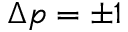<formula> <loc_0><loc_0><loc_500><loc_500>\Delta p = \pm 1</formula> 